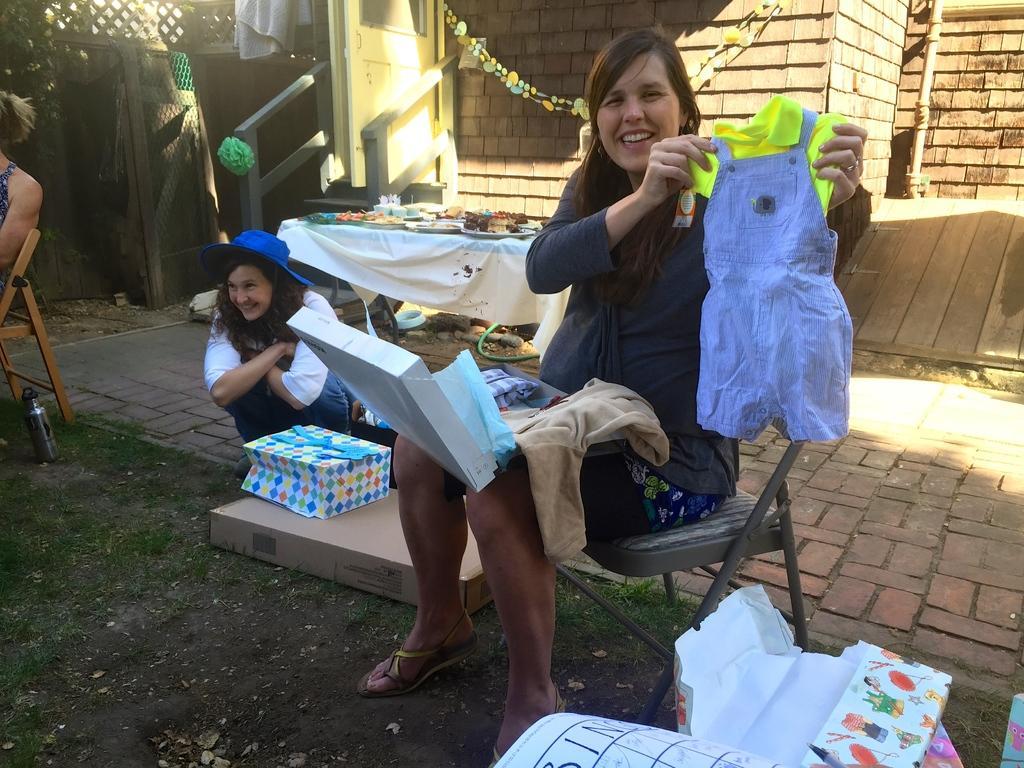Could you give a brief overview of what you see in this image? In this picture a woman wearing a black jacket and showing the small baby dress smiling and giving a pose into the camera. Beside we can see a woman wearing blue color shirt sitting on ground and smiling. Behind we can see the table with many cupcakes. In the background there is a wooden pattern brick house. 